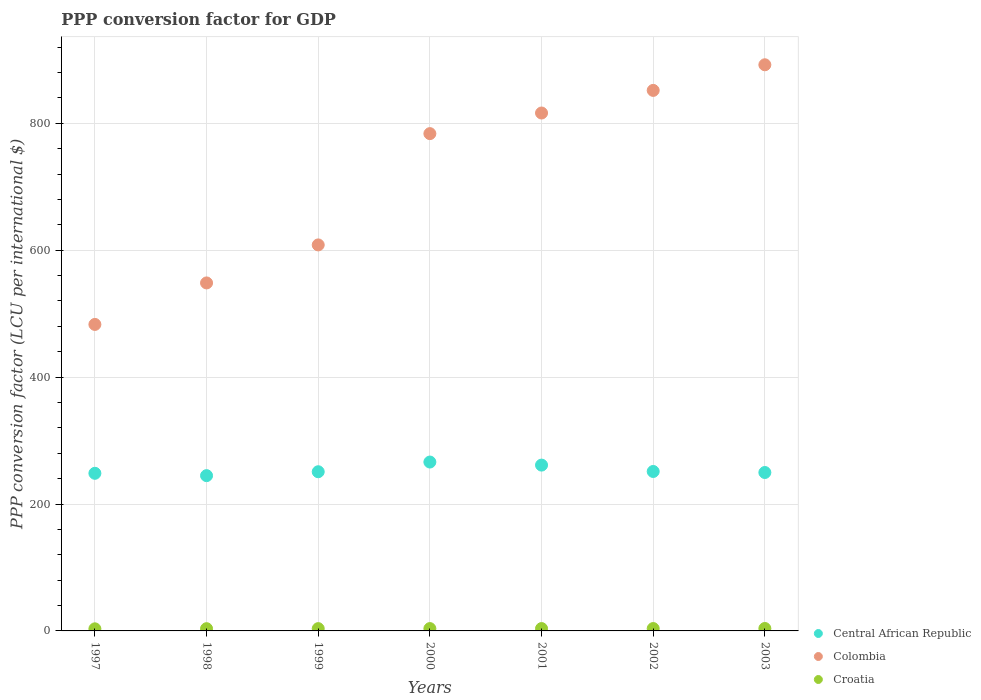How many different coloured dotlines are there?
Make the answer very short. 3. Is the number of dotlines equal to the number of legend labels?
Offer a terse response. Yes. What is the PPP conversion factor for GDP in Colombia in 2000?
Your answer should be compact. 783.73. Across all years, what is the maximum PPP conversion factor for GDP in Central African Republic?
Make the answer very short. 266.16. Across all years, what is the minimum PPP conversion factor for GDP in Croatia?
Make the answer very short. 3.3. In which year was the PPP conversion factor for GDP in Colombia maximum?
Your answer should be very brief. 2003. What is the total PPP conversion factor for GDP in Colombia in the graph?
Provide a short and direct response. 4983.86. What is the difference between the PPP conversion factor for GDP in Croatia in 1998 and that in 2001?
Provide a succinct answer. -0.19. What is the difference between the PPP conversion factor for GDP in Colombia in 2002 and the PPP conversion factor for GDP in Croatia in 1997?
Provide a short and direct response. 848.56. What is the average PPP conversion factor for GDP in Colombia per year?
Make the answer very short. 711.98. In the year 1998, what is the difference between the PPP conversion factor for GDP in Colombia and PPP conversion factor for GDP in Central African Republic?
Your answer should be compact. 303.71. In how many years, is the PPP conversion factor for GDP in Central African Republic greater than 480 LCU?
Offer a terse response. 0. What is the ratio of the PPP conversion factor for GDP in Central African Republic in 1997 to that in 2002?
Make the answer very short. 0.99. Is the difference between the PPP conversion factor for GDP in Colombia in 1998 and 2000 greater than the difference between the PPP conversion factor for GDP in Central African Republic in 1998 and 2000?
Make the answer very short. No. What is the difference between the highest and the second highest PPP conversion factor for GDP in Croatia?
Your response must be concise. 0.1. What is the difference between the highest and the lowest PPP conversion factor for GDP in Central African Republic?
Ensure brevity in your answer.  21.44. In how many years, is the PPP conversion factor for GDP in Central African Republic greater than the average PPP conversion factor for GDP in Central African Republic taken over all years?
Ensure brevity in your answer.  2. Is the sum of the PPP conversion factor for GDP in Colombia in 1998 and 1999 greater than the maximum PPP conversion factor for GDP in Croatia across all years?
Your answer should be very brief. Yes. Is it the case that in every year, the sum of the PPP conversion factor for GDP in Central African Republic and PPP conversion factor for GDP in Croatia  is greater than the PPP conversion factor for GDP in Colombia?
Keep it short and to the point. No. Does the PPP conversion factor for GDP in Central African Republic monotonically increase over the years?
Your response must be concise. No. Is the PPP conversion factor for GDP in Croatia strictly greater than the PPP conversion factor for GDP in Colombia over the years?
Offer a very short reply. No. How many years are there in the graph?
Your response must be concise. 7. What is the difference between two consecutive major ticks on the Y-axis?
Offer a terse response. 200. Are the values on the major ticks of Y-axis written in scientific E-notation?
Provide a short and direct response. No. Does the graph contain grids?
Your answer should be compact. Yes. Where does the legend appear in the graph?
Keep it short and to the point. Bottom right. How are the legend labels stacked?
Provide a short and direct response. Vertical. What is the title of the graph?
Your answer should be very brief. PPP conversion factor for GDP. What is the label or title of the X-axis?
Make the answer very short. Years. What is the label or title of the Y-axis?
Offer a terse response. PPP conversion factor (LCU per international $). What is the PPP conversion factor (LCU per international $) in Central African Republic in 1997?
Offer a terse response. 248.4. What is the PPP conversion factor (LCU per international $) of Colombia in 1997?
Your response must be concise. 483.02. What is the PPP conversion factor (LCU per international $) in Croatia in 1997?
Offer a very short reply. 3.3. What is the PPP conversion factor (LCU per international $) of Central African Republic in 1998?
Provide a succinct answer. 244.72. What is the PPP conversion factor (LCU per international $) of Colombia in 1998?
Keep it short and to the point. 548.43. What is the PPP conversion factor (LCU per international $) of Croatia in 1998?
Provide a short and direct response. 3.52. What is the PPP conversion factor (LCU per international $) of Central African Republic in 1999?
Make the answer very short. 250.87. What is the PPP conversion factor (LCU per international $) in Colombia in 1999?
Give a very brief answer. 608.35. What is the PPP conversion factor (LCU per international $) of Croatia in 1999?
Provide a succinct answer. 3.62. What is the PPP conversion factor (LCU per international $) in Central African Republic in 2000?
Keep it short and to the point. 266.16. What is the PPP conversion factor (LCU per international $) of Colombia in 2000?
Keep it short and to the point. 783.73. What is the PPP conversion factor (LCU per international $) in Croatia in 2000?
Offer a very short reply. 3.68. What is the PPP conversion factor (LCU per international $) of Central African Republic in 2001?
Your answer should be very brief. 261.34. What is the PPP conversion factor (LCU per international $) of Colombia in 2001?
Make the answer very short. 816.22. What is the PPP conversion factor (LCU per international $) of Croatia in 2001?
Provide a short and direct response. 3.71. What is the PPP conversion factor (LCU per international $) in Central African Republic in 2002?
Give a very brief answer. 251.28. What is the PPP conversion factor (LCU per international $) in Colombia in 2002?
Provide a succinct answer. 851.86. What is the PPP conversion factor (LCU per international $) in Croatia in 2002?
Offer a very short reply. 3.74. What is the PPP conversion factor (LCU per international $) in Central African Republic in 2003?
Offer a terse response. 249.66. What is the PPP conversion factor (LCU per international $) of Colombia in 2003?
Give a very brief answer. 892.24. What is the PPP conversion factor (LCU per international $) in Croatia in 2003?
Offer a very short reply. 3.84. Across all years, what is the maximum PPP conversion factor (LCU per international $) in Central African Republic?
Keep it short and to the point. 266.16. Across all years, what is the maximum PPP conversion factor (LCU per international $) in Colombia?
Give a very brief answer. 892.24. Across all years, what is the maximum PPP conversion factor (LCU per international $) of Croatia?
Your answer should be compact. 3.84. Across all years, what is the minimum PPP conversion factor (LCU per international $) of Central African Republic?
Keep it short and to the point. 244.72. Across all years, what is the minimum PPP conversion factor (LCU per international $) of Colombia?
Ensure brevity in your answer.  483.02. Across all years, what is the minimum PPP conversion factor (LCU per international $) in Croatia?
Make the answer very short. 3.3. What is the total PPP conversion factor (LCU per international $) in Central African Republic in the graph?
Make the answer very short. 1772.43. What is the total PPP conversion factor (LCU per international $) in Colombia in the graph?
Your answer should be compact. 4983.86. What is the total PPP conversion factor (LCU per international $) of Croatia in the graph?
Make the answer very short. 25.41. What is the difference between the PPP conversion factor (LCU per international $) of Central African Republic in 1997 and that in 1998?
Provide a succinct answer. 3.68. What is the difference between the PPP conversion factor (LCU per international $) of Colombia in 1997 and that in 1998?
Keep it short and to the point. -65.41. What is the difference between the PPP conversion factor (LCU per international $) of Croatia in 1997 and that in 1998?
Offer a terse response. -0.22. What is the difference between the PPP conversion factor (LCU per international $) of Central African Republic in 1997 and that in 1999?
Offer a very short reply. -2.47. What is the difference between the PPP conversion factor (LCU per international $) of Colombia in 1997 and that in 1999?
Offer a terse response. -125.32. What is the difference between the PPP conversion factor (LCU per international $) in Croatia in 1997 and that in 1999?
Your answer should be compact. -0.31. What is the difference between the PPP conversion factor (LCU per international $) in Central African Republic in 1997 and that in 2000?
Ensure brevity in your answer.  -17.76. What is the difference between the PPP conversion factor (LCU per international $) in Colombia in 1997 and that in 2000?
Your answer should be compact. -300.71. What is the difference between the PPP conversion factor (LCU per international $) of Croatia in 1997 and that in 2000?
Offer a terse response. -0.38. What is the difference between the PPP conversion factor (LCU per international $) of Central African Republic in 1997 and that in 2001?
Keep it short and to the point. -12.94. What is the difference between the PPP conversion factor (LCU per international $) in Colombia in 1997 and that in 2001?
Offer a very short reply. -333.2. What is the difference between the PPP conversion factor (LCU per international $) in Croatia in 1997 and that in 2001?
Give a very brief answer. -0.41. What is the difference between the PPP conversion factor (LCU per international $) in Central African Republic in 1997 and that in 2002?
Ensure brevity in your answer.  -2.88. What is the difference between the PPP conversion factor (LCU per international $) in Colombia in 1997 and that in 2002?
Offer a terse response. -368.83. What is the difference between the PPP conversion factor (LCU per international $) of Croatia in 1997 and that in 2002?
Offer a very short reply. -0.44. What is the difference between the PPP conversion factor (LCU per international $) of Central African Republic in 1997 and that in 2003?
Offer a terse response. -1.26. What is the difference between the PPP conversion factor (LCU per international $) of Colombia in 1997 and that in 2003?
Offer a very short reply. -409.21. What is the difference between the PPP conversion factor (LCU per international $) in Croatia in 1997 and that in 2003?
Ensure brevity in your answer.  -0.53. What is the difference between the PPP conversion factor (LCU per international $) of Central African Republic in 1998 and that in 1999?
Your response must be concise. -6.16. What is the difference between the PPP conversion factor (LCU per international $) in Colombia in 1998 and that in 1999?
Provide a succinct answer. -59.92. What is the difference between the PPP conversion factor (LCU per international $) of Croatia in 1998 and that in 1999?
Keep it short and to the point. -0.09. What is the difference between the PPP conversion factor (LCU per international $) in Central African Republic in 1998 and that in 2000?
Provide a succinct answer. -21.44. What is the difference between the PPP conversion factor (LCU per international $) of Colombia in 1998 and that in 2000?
Provide a short and direct response. -235.3. What is the difference between the PPP conversion factor (LCU per international $) in Croatia in 1998 and that in 2000?
Offer a terse response. -0.16. What is the difference between the PPP conversion factor (LCU per international $) of Central African Republic in 1998 and that in 2001?
Your answer should be very brief. -16.62. What is the difference between the PPP conversion factor (LCU per international $) in Colombia in 1998 and that in 2001?
Keep it short and to the point. -267.79. What is the difference between the PPP conversion factor (LCU per international $) in Croatia in 1998 and that in 2001?
Give a very brief answer. -0.19. What is the difference between the PPP conversion factor (LCU per international $) in Central African Republic in 1998 and that in 2002?
Offer a terse response. -6.56. What is the difference between the PPP conversion factor (LCU per international $) in Colombia in 1998 and that in 2002?
Your answer should be compact. -303.43. What is the difference between the PPP conversion factor (LCU per international $) in Croatia in 1998 and that in 2002?
Your answer should be very brief. -0.22. What is the difference between the PPP conversion factor (LCU per international $) of Central African Republic in 1998 and that in 2003?
Your answer should be compact. -4.94. What is the difference between the PPP conversion factor (LCU per international $) of Colombia in 1998 and that in 2003?
Make the answer very short. -343.81. What is the difference between the PPP conversion factor (LCU per international $) in Croatia in 1998 and that in 2003?
Offer a very short reply. -0.32. What is the difference between the PPP conversion factor (LCU per international $) in Central African Republic in 1999 and that in 2000?
Give a very brief answer. -15.28. What is the difference between the PPP conversion factor (LCU per international $) of Colombia in 1999 and that in 2000?
Your answer should be very brief. -175.39. What is the difference between the PPP conversion factor (LCU per international $) in Croatia in 1999 and that in 2000?
Keep it short and to the point. -0.07. What is the difference between the PPP conversion factor (LCU per international $) in Central African Republic in 1999 and that in 2001?
Your answer should be compact. -10.46. What is the difference between the PPP conversion factor (LCU per international $) of Colombia in 1999 and that in 2001?
Give a very brief answer. -207.87. What is the difference between the PPP conversion factor (LCU per international $) in Croatia in 1999 and that in 2001?
Ensure brevity in your answer.  -0.1. What is the difference between the PPP conversion factor (LCU per international $) in Central African Republic in 1999 and that in 2002?
Offer a terse response. -0.41. What is the difference between the PPP conversion factor (LCU per international $) in Colombia in 1999 and that in 2002?
Provide a succinct answer. -243.51. What is the difference between the PPP conversion factor (LCU per international $) of Croatia in 1999 and that in 2002?
Your answer should be compact. -0.13. What is the difference between the PPP conversion factor (LCU per international $) in Central African Republic in 1999 and that in 2003?
Offer a very short reply. 1.21. What is the difference between the PPP conversion factor (LCU per international $) in Colombia in 1999 and that in 2003?
Give a very brief answer. -283.89. What is the difference between the PPP conversion factor (LCU per international $) of Croatia in 1999 and that in 2003?
Make the answer very short. -0.22. What is the difference between the PPP conversion factor (LCU per international $) of Central African Republic in 2000 and that in 2001?
Ensure brevity in your answer.  4.82. What is the difference between the PPP conversion factor (LCU per international $) of Colombia in 2000 and that in 2001?
Offer a very short reply. -32.49. What is the difference between the PPP conversion factor (LCU per international $) in Croatia in 2000 and that in 2001?
Give a very brief answer. -0.03. What is the difference between the PPP conversion factor (LCU per international $) of Central African Republic in 2000 and that in 2002?
Your answer should be compact. 14.88. What is the difference between the PPP conversion factor (LCU per international $) of Colombia in 2000 and that in 2002?
Provide a short and direct response. -68.12. What is the difference between the PPP conversion factor (LCU per international $) of Croatia in 2000 and that in 2002?
Offer a very short reply. -0.06. What is the difference between the PPP conversion factor (LCU per international $) in Central African Republic in 2000 and that in 2003?
Keep it short and to the point. 16.5. What is the difference between the PPP conversion factor (LCU per international $) of Colombia in 2000 and that in 2003?
Provide a succinct answer. -108.5. What is the difference between the PPP conversion factor (LCU per international $) of Croatia in 2000 and that in 2003?
Ensure brevity in your answer.  -0.15. What is the difference between the PPP conversion factor (LCU per international $) in Central African Republic in 2001 and that in 2002?
Give a very brief answer. 10.06. What is the difference between the PPP conversion factor (LCU per international $) in Colombia in 2001 and that in 2002?
Offer a terse response. -35.64. What is the difference between the PPP conversion factor (LCU per international $) in Croatia in 2001 and that in 2002?
Ensure brevity in your answer.  -0.03. What is the difference between the PPP conversion factor (LCU per international $) of Central African Republic in 2001 and that in 2003?
Make the answer very short. 11.68. What is the difference between the PPP conversion factor (LCU per international $) of Colombia in 2001 and that in 2003?
Offer a very short reply. -76.02. What is the difference between the PPP conversion factor (LCU per international $) in Croatia in 2001 and that in 2003?
Make the answer very short. -0.13. What is the difference between the PPP conversion factor (LCU per international $) of Central African Republic in 2002 and that in 2003?
Make the answer very short. 1.62. What is the difference between the PPP conversion factor (LCU per international $) of Colombia in 2002 and that in 2003?
Give a very brief answer. -40.38. What is the difference between the PPP conversion factor (LCU per international $) of Croatia in 2002 and that in 2003?
Your response must be concise. -0.1. What is the difference between the PPP conversion factor (LCU per international $) of Central African Republic in 1997 and the PPP conversion factor (LCU per international $) of Colombia in 1998?
Offer a terse response. -300.03. What is the difference between the PPP conversion factor (LCU per international $) in Central African Republic in 1997 and the PPP conversion factor (LCU per international $) in Croatia in 1998?
Give a very brief answer. 244.88. What is the difference between the PPP conversion factor (LCU per international $) in Colombia in 1997 and the PPP conversion factor (LCU per international $) in Croatia in 1998?
Give a very brief answer. 479.5. What is the difference between the PPP conversion factor (LCU per international $) of Central African Republic in 1997 and the PPP conversion factor (LCU per international $) of Colombia in 1999?
Your answer should be very brief. -359.95. What is the difference between the PPP conversion factor (LCU per international $) of Central African Republic in 1997 and the PPP conversion factor (LCU per international $) of Croatia in 1999?
Your answer should be compact. 244.79. What is the difference between the PPP conversion factor (LCU per international $) of Colombia in 1997 and the PPP conversion factor (LCU per international $) of Croatia in 1999?
Offer a very short reply. 479.41. What is the difference between the PPP conversion factor (LCU per international $) in Central African Republic in 1997 and the PPP conversion factor (LCU per international $) in Colombia in 2000?
Your answer should be compact. -535.33. What is the difference between the PPP conversion factor (LCU per international $) in Central African Republic in 1997 and the PPP conversion factor (LCU per international $) in Croatia in 2000?
Ensure brevity in your answer.  244.72. What is the difference between the PPP conversion factor (LCU per international $) of Colombia in 1997 and the PPP conversion factor (LCU per international $) of Croatia in 2000?
Your answer should be very brief. 479.34. What is the difference between the PPP conversion factor (LCU per international $) in Central African Republic in 1997 and the PPP conversion factor (LCU per international $) in Colombia in 2001?
Ensure brevity in your answer.  -567.82. What is the difference between the PPP conversion factor (LCU per international $) in Central African Republic in 1997 and the PPP conversion factor (LCU per international $) in Croatia in 2001?
Provide a succinct answer. 244.69. What is the difference between the PPP conversion factor (LCU per international $) of Colombia in 1997 and the PPP conversion factor (LCU per international $) of Croatia in 2001?
Your answer should be compact. 479.31. What is the difference between the PPP conversion factor (LCU per international $) in Central African Republic in 1997 and the PPP conversion factor (LCU per international $) in Colombia in 2002?
Make the answer very short. -603.46. What is the difference between the PPP conversion factor (LCU per international $) of Central African Republic in 1997 and the PPP conversion factor (LCU per international $) of Croatia in 2002?
Make the answer very short. 244.66. What is the difference between the PPP conversion factor (LCU per international $) of Colombia in 1997 and the PPP conversion factor (LCU per international $) of Croatia in 2002?
Provide a succinct answer. 479.28. What is the difference between the PPP conversion factor (LCU per international $) in Central African Republic in 1997 and the PPP conversion factor (LCU per international $) in Colombia in 2003?
Provide a short and direct response. -643.84. What is the difference between the PPP conversion factor (LCU per international $) in Central African Republic in 1997 and the PPP conversion factor (LCU per international $) in Croatia in 2003?
Give a very brief answer. 244.57. What is the difference between the PPP conversion factor (LCU per international $) of Colombia in 1997 and the PPP conversion factor (LCU per international $) of Croatia in 2003?
Ensure brevity in your answer.  479.19. What is the difference between the PPP conversion factor (LCU per international $) of Central African Republic in 1998 and the PPP conversion factor (LCU per international $) of Colombia in 1999?
Provide a succinct answer. -363.63. What is the difference between the PPP conversion factor (LCU per international $) in Central African Republic in 1998 and the PPP conversion factor (LCU per international $) in Croatia in 1999?
Your response must be concise. 241.1. What is the difference between the PPP conversion factor (LCU per international $) of Colombia in 1998 and the PPP conversion factor (LCU per international $) of Croatia in 1999?
Your response must be concise. 544.82. What is the difference between the PPP conversion factor (LCU per international $) in Central African Republic in 1998 and the PPP conversion factor (LCU per international $) in Colombia in 2000?
Your answer should be very brief. -539.02. What is the difference between the PPP conversion factor (LCU per international $) in Central African Republic in 1998 and the PPP conversion factor (LCU per international $) in Croatia in 2000?
Offer a very short reply. 241.04. What is the difference between the PPP conversion factor (LCU per international $) in Colombia in 1998 and the PPP conversion factor (LCU per international $) in Croatia in 2000?
Your response must be concise. 544.75. What is the difference between the PPP conversion factor (LCU per international $) of Central African Republic in 1998 and the PPP conversion factor (LCU per international $) of Colombia in 2001?
Ensure brevity in your answer.  -571.5. What is the difference between the PPP conversion factor (LCU per international $) in Central African Republic in 1998 and the PPP conversion factor (LCU per international $) in Croatia in 2001?
Offer a very short reply. 241.01. What is the difference between the PPP conversion factor (LCU per international $) in Colombia in 1998 and the PPP conversion factor (LCU per international $) in Croatia in 2001?
Your answer should be compact. 544.72. What is the difference between the PPP conversion factor (LCU per international $) in Central African Republic in 1998 and the PPP conversion factor (LCU per international $) in Colombia in 2002?
Give a very brief answer. -607.14. What is the difference between the PPP conversion factor (LCU per international $) of Central African Republic in 1998 and the PPP conversion factor (LCU per international $) of Croatia in 2002?
Your response must be concise. 240.98. What is the difference between the PPP conversion factor (LCU per international $) of Colombia in 1998 and the PPP conversion factor (LCU per international $) of Croatia in 2002?
Your answer should be very brief. 544.69. What is the difference between the PPP conversion factor (LCU per international $) in Central African Republic in 1998 and the PPP conversion factor (LCU per international $) in Colombia in 2003?
Offer a terse response. -647.52. What is the difference between the PPP conversion factor (LCU per international $) of Central African Republic in 1998 and the PPP conversion factor (LCU per international $) of Croatia in 2003?
Your answer should be very brief. 240.88. What is the difference between the PPP conversion factor (LCU per international $) in Colombia in 1998 and the PPP conversion factor (LCU per international $) in Croatia in 2003?
Ensure brevity in your answer.  544.59. What is the difference between the PPP conversion factor (LCU per international $) of Central African Republic in 1999 and the PPP conversion factor (LCU per international $) of Colombia in 2000?
Your answer should be compact. -532.86. What is the difference between the PPP conversion factor (LCU per international $) of Central African Republic in 1999 and the PPP conversion factor (LCU per international $) of Croatia in 2000?
Your answer should be very brief. 247.19. What is the difference between the PPP conversion factor (LCU per international $) of Colombia in 1999 and the PPP conversion factor (LCU per international $) of Croatia in 2000?
Your answer should be compact. 604.67. What is the difference between the PPP conversion factor (LCU per international $) of Central African Republic in 1999 and the PPP conversion factor (LCU per international $) of Colombia in 2001?
Provide a succinct answer. -565.35. What is the difference between the PPP conversion factor (LCU per international $) in Central African Republic in 1999 and the PPP conversion factor (LCU per international $) in Croatia in 2001?
Your answer should be very brief. 247.16. What is the difference between the PPP conversion factor (LCU per international $) in Colombia in 1999 and the PPP conversion factor (LCU per international $) in Croatia in 2001?
Ensure brevity in your answer.  604.64. What is the difference between the PPP conversion factor (LCU per international $) in Central African Republic in 1999 and the PPP conversion factor (LCU per international $) in Colombia in 2002?
Offer a terse response. -600.98. What is the difference between the PPP conversion factor (LCU per international $) in Central African Republic in 1999 and the PPP conversion factor (LCU per international $) in Croatia in 2002?
Your response must be concise. 247.13. What is the difference between the PPP conversion factor (LCU per international $) of Colombia in 1999 and the PPP conversion factor (LCU per international $) of Croatia in 2002?
Keep it short and to the point. 604.61. What is the difference between the PPP conversion factor (LCU per international $) of Central African Republic in 1999 and the PPP conversion factor (LCU per international $) of Colombia in 2003?
Your response must be concise. -641.36. What is the difference between the PPP conversion factor (LCU per international $) in Central African Republic in 1999 and the PPP conversion factor (LCU per international $) in Croatia in 2003?
Your answer should be very brief. 247.04. What is the difference between the PPP conversion factor (LCU per international $) of Colombia in 1999 and the PPP conversion factor (LCU per international $) of Croatia in 2003?
Offer a very short reply. 604.51. What is the difference between the PPP conversion factor (LCU per international $) of Central African Republic in 2000 and the PPP conversion factor (LCU per international $) of Colombia in 2001?
Your answer should be compact. -550.06. What is the difference between the PPP conversion factor (LCU per international $) of Central African Republic in 2000 and the PPP conversion factor (LCU per international $) of Croatia in 2001?
Ensure brevity in your answer.  262.45. What is the difference between the PPP conversion factor (LCU per international $) in Colombia in 2000 and the PPP conversion factor (LCU per international $) in Croatia in 2001?
Provide a short and direct response. 780.02. What is the difference between the PPP conversion factor (LCU per international $) in Central African Republic in 2000 and the PPP conversion factor (LCU per international $) in Colombia in 2002?
Offer a terse response. -585.7. What is the difference between the PPP conversion factor (LCU per international $) in Central African Republic in 2000 and the PPP conversion factor (LCU per international $) in Croatia in 2002?
Give a very brief answer. 262.42. What is the difference between the PPP conversion factor (LCU per international $) of Colombia in 2000 and the PPP conversion factor (LCU per international $) of Croatia in 2002?
Give a very brief answer. 779.99. What is the difference between the PPP conversion factor (LCU per international $) of Central African Republic in 2000 and the PPP conversion factor (LCU per international $) of Colombia in 2003?
Your answer should be very brief. -626.08. What is the difference between the PPP conversion factor (LCU per international $) in Central African Republic in 2000 and the PPP conversion factor (LCU per international $) in Croatia in 2003?
Give a very brief answer. 262.32. What is the difference between the PPP conversion factor (LCU per international $) in Colombia in 2000 and the PPP conversion factor (LCU per international $) in Croatia in 2003?
Provide a short and direct response. 779.9. What is the difference between the PPP conversion factor (LCU per international $) in Central African Republic in 2001 and the PPP conversion factor (LCU per international $) in Colombia in 2002?
Offer a terse response. -590.52. What is the difference between the PPP conversion factor (LCU per international $) of Central African Republic in 2001 and the PPP conversion factor (LCU per international $) of Croatia in 2002?
Give a very brief answer. 257.6. What is the difference between the PPP conversion factor (LCU per international $) of Colombia in 2001 and the PPP conversion factor (LCU per international $) of Croatia in 2002?
Make the answer very short. 812.48. What is the difference between the PPP conversion factor (LCU per international $) of Central African Republic in 2001 and the PPP conversion factor (LCU per international $) of Colombia in 2003?
Your answer should be very brief. -630.9. What is the difference between the PPP conversion factor (LCU per international $) of Central African Republic in 2001 and the PPP conversion factor (LCU per international $) of Croatia in 2003?
Your response must be concise. 257.5. What is the difference between the PPP conversion factor (LCU per international $) of Colombia in 2001 and the PPP conversion factor (LCU per international $) of Croatia in 2003?
Keep it short and to the point. 812.38. What is the difference between the PPP conversion factor (LCU per international $) in Central African Republic in 2002 and the PPP conversion factor (LCU per international $) in Colombia in 2003?
Offer a terse response. -640.96. What is the difference between the PPP conversion factor (LCU per international $) of Central African Republic in 2002 and the PPP conversion factor (LCU per international $) of Croatia in 2003?
Your answer should be very brief. 247.45. What is the difference between the PPP conversion factor (LCU per international $) in Colombia in 2002 and the PPP conversion factor (LCU per international $) in Croatia in 2003?
Give a very brief answer. 848.02. What is the average PPP conversion factor (LCU per international $) of Central African Republic per year?
Provide a short and direct response. 253.21. What is the average PPP conversion factor (LCU per international $) of Colombia per year?
Provide a succinct answer. 711.98. What is the average PPP conversion factor (LCU per international $) in Croatia per year?
Keep it short and to the point. 3.63. In the year 1997, what is the difference between the PPP conversion factor (LCU per international $) in Central African Republic and PPP conversion factor (LCU per international $) in Colombia?
Provide a short and direct response. -234.62. In the year 1997, what is the difference between the PPP conversion factor (LCU per international $) in Central African Republic and PPP conversion factor (LCU per international $) in Croatia?
Your answer should be very brief. 245.1. In the year 1997, what is the difference between the PPP conversion factor (LCU per international $) of Colombia and PPP conversion factor (LCU per international $) of Croatia?
Make the answer very short. 479.72. In the year 1998, what is the difference between the PPP conversion factor (LCU per international $) of Central African Republic and PPP conversion factor (LCU per international $) of Colombia?
Make the answer very short. -303.71. In the year 1998, what is the difference between the PPP conversion factor (LCU per international $) of Central African Republic and PPP conversion factor (LCU per international $) of Croatia?
Keep it short and to the point. 241.2. In the year 1998, what is the difference between the PPP conversion factor (LCU per international $) in Colombia and PPP conversion factor (LCU per international $) in Croatia?
Ensure brevity in your answer.  544.91. In the year 1999, what is the difference between the PPP conversion factor (LCU per international $) in Central African Republic and PPP conversion factor (LCU per international $) in Colombia?
Your answer should be very brief. -357.47. In the year 1999, what is the difference between the PPP conversion factor (LCU per international $) in Central African Republic and PPP conversion factor (LCU per international $) in Croatia?
Provide a succinct answer. 247.26. In the year 1999, what is the difference between the PPP conversion factor (LCU per international $) in Colombia and PPP conversion factor (LCU per international $) in Croatia?
Ensure brevity in your answer.  604.73. In the year 2000, what is the difference between the PPP conversion factor (LCU per international $) in Central African Republic and PPP conversion factor (LCU per international $) in Colombia?
Offer a very short reply. -517.58. In the year 2000, what is the difference between the PPP conversion factor (LCU per international $) of Central African Republic and PPP conversion factor (LCU per international $) of Croatia?
Provide a short and direct response. 262.48. In the year 2000, what is the difference between the PPP conversion factor (LCU per international $) in Colombia and PPP conversion factor (LCU per international $) in Croatia?
Provide a short and direct response. 780.05. In the year 2001, what is the difference between the PPP conversion factor (LCU per international $) in Central African Republic and PPP conversion factor (LCU per international $) in Colombia?
Ensure brevity in your answer.  -554.88. In the year 2001, what is the difference between the PPP conversion factor (LCU per international $) in Central African Republic and PPP conversion factor (LCU per international $) in Croatia?
Offer a very short reply. 257.63. In the year 2001, what is the difference between the PPP conversion factor (LCU per international $) of Colombia and PPP conversion factor (LCU per international $) of Croatia?
Your answer should be compact. 812.51. In the year 2002, what is the difference between the PPP conversion factor (LCU per international $) in Central African Republic and PPP conversion factor (LCU per international $) in Colombia?
Provide a succinct answer. -600.58. In the year 2002, what is the difference between the PPP conversion factor (LCU per international $) of Central African Republic and PPP conversion factor (LCU per international $) of Croatia?
Your response must be concise. 247.54. In the year 2002, what is the difference between the PPP conversion factor (LCU per international $) of Colombia and PPP conversion factor (LCU per international $) of Croatia?
Keep it short and to the point. 848.12. In the year 2003, what is the difference between the PPP conversion factor (LCU per international $) in Central African Republic and PPP conversion factor (LCU per international $) in Colombia?
Make the answer very short. -642.58. In the year 2003, what is the difference between the PPP conversion factor (LCU per international $) in Central African Republic and PPP conversion factor (LCU per international $) in Croatia?
Give a very brief answer. 245.82. In the year 2003, what is the difference between the PPP conversion factor (LCU per international $) in Colombia and PPP conversion factor (LCU per international $) in Croatia?
Your response must be concise. 888.4. What is the ratio of the PPP conversion factor (LCU per international $) in Central African Republic in 1997 to that in 1998?
Your response must be concise. 1.02. What is the ratio of the PPP conversion factor (LCU per international $) in Colombia in 1997 to that in 1998?
Your answer should be compact. 0.88. What is the ratio of the PPP conversion factor (LCU per international $) of Croatia in 1997 to that in 1998?
Provide a succinct answer. 0.94. What is the ratio of the PPP conversion factor (LCU per international $) of Central African Republic in 1997 to that in 1999?
Make the answer very short. 0.99. What is the ratio of the PPP conversion factor (LCU per international $) in Colombia in 1997 to that in 1999?
Provide a succinct answer. 0.79. What is the ratio of the PPP conversion factor (LCU per international $) in Croatia in 1997 to that in 1999?
Provide a succinct answer. 0.91. What is the ratio of the PPP conversion factor (LCU per international $) in Colombia in 1997 to that in 2000?
Your answer should be very brief. 0.62. What is the ratio of the PPP conversion factor (LCU per international $) in Croatia in 1997 to that in 2000?
Keep it short and to the point. 0.9. What is the ratio of the PPP conversion factor (LCU per international $) in Central African Republic in 1997 to that in 2001?
Provide a succinct answer. 0.95. What is the ratio of the PPP conversion factor (LCU per international $) of Colombia in 1997 to that in 2001?
Provide a short and direct response. 0.59. What is the ratio of the PPP conversion factor (LCU per international $) in Croatia in 1997 to that in 2001?
Your answer should be very brief. 0.89. What is the ratio of the PPP conversion factor (LCU per international $) in Colombia in 1997 to that in 2002?
Provide a succinct answer. 0.57. What is the ratio of the PPP conversion factor (LCU per international $) in Croatia in 1997 to that in 2002?
Your answer should be very brief. 0.88. What is the ratio of the PPP conversion factor (LCU per international $) in Colombia in 1997 to that in 2003?
Your answer should be very brief. 0.54. What is the ratio of the PPP conversion factor (LCU per international $) of Croatia in 1997 to that in 2003?
Give a very brief answer. 0.86. What is the ratio of the PPP conversion factor (LCU per international $) of Central African Republic in 1998 to that in 1999?
Provide a succinct answer. 0.98. What is the ratio of the PPP conversion factor (LCU per international $) of Colombia in 1998 to that in 1999?
Ensure brevity in your answer.  0.9. What is the ratio of the PPP conversion factor (LCU per international $) of Croatia in 1998 to that in 1999?
Your response must be concise. 0.97. What is the ratio of the PPP conversion factor (LCU per international $) in Central African Republic in 1998 to that in 2000?
Your answer should be very brief. 0.92. What is the ratio of the PPP conversion factor (LCU per international $) in Colombia in 1998 to that in 2000?
Make the answer very short. 0.7. What is the ratio of the PPP conversion factor (LCU per international $) in Croatia in 1998 to that in 2000?
Provide a succinct answer. 0.96. What is the ratio of the PPP conversion factor (LCU per international $) in Central African Republic in 1998 to that in 2001?
Keep it short and to the point. 0.94. What is the ratio of the PPP conversion factor (LCU per international $) in Colombia in 1998 to that in 2001?
Offer a terse response. 0.67. What is the ratio of the PPP conversion factor (LCU per international $) of Croatia in 1998 to that in 2001?
Offer a terse response. 0.95. What is the ratio of the PPP conversion factor (LCU per international $) of Central African Republic in 1998 to that in 2002?
Offer a terse response. 0.97. What is the ratio of the PPP conversion factor (LCU per international $) in Colombia in 1998 to that in 2002?
Make the answer very short. 0.64. What is the ratio of the PPP conversion factor (LCU per international $) of Croatia in 1998 to that in 2002?
Offer a terse response. 0.94. What is the ratio of the PPP conversion factor (LCU per international $) of Central African Republic in 1998 to that in 2003?
Your response must be concise. 0.98. What is the ratio of the PPP conversion factor (LCU per international $) in Colombia in 1998 to that in 2003?
Offer a very short reply. 0.61. What is the ratio of the PPP conversion factor (LCU per international $) of Croatia in 1998 to that in 2003?
Your answer should be very brief. 0.92. What is the ratio of the PPP conversion factor (LCU per international $) in Central African Republic in 1999 to that in 2000?
Offer a very short reply. 0.94. What is the ratio of the PPP conversion factor (LCU per international $) of Colombia in 1999 to that in 2000?
Offer a terse response. 0.78. What is the ratio of the PPP conversion factor (LCU per international $) in Croatia in 1999 to that in 2000?
Provide a short and direct response. 0.98. What is the ratio of the PPP conversion factor (LCU per international $) in Colombia in 1999 to that in 2001?
Offer a terse response. 0.75. What is the ratio of the PPP conversion factor (LCU per international $) of Croatia in 1999 to that in 2001?
Ensure brevity in your answer.  0.97. What is the ratio of the PPP conversion factor (LCU per international $) in Colombia in 1999 to that in 2002?
Offer a very short reply. 0.71. What is the ratio of the PPP conversion factor (LCU per international $) in Croatia in 1999 to that in 2002?
Give a very brief answer. 0.97. What is the ratio of the PPP conversion factor (LCU per international $) in Central African Republic in 1999 to that in 2003?
Offer a terse response. 1. What is the ratio of the PPP conversion factor (LCU per international $) of Colombia in 1999 to that in 2003?
Offer a terse response. 0.68. What is the ratio of the PPP conversion factor (LCU per international $) in Croatia in 1999 to that in 2003?
Make the answer very short. 0.94. What is the ratio of the PPP conversion factor (LCU per international $) of Central African Republic in 2000 to that in 2001?
Make the answer very short. 1.02. What is the ratio of the PPP conversion factor (LCU per international $) of Colombia in 2000 to that in 2001?
Offer a very short reply. 0.96. What is the ratio of the PPP conversion factor (LCU per international $) in Croatia in 2000 to that in 2001?
Provide a succinct answer. 0.99. What is the ratio of the PPP conversion factor (LCU per international $) in Central African Republic in 2000 to that in 2002?
Provide a succinct answer. 1.06. What is the ratio of the PPP conversion factor (LCU per international $) in Croatia in 2000 to that in 2002?
Your answer should be very brief. 0.98. What is the ratio of the PPP conversion factor (LCU per international $) in Central African Republic in 2000 to that in 2003?
Your response must be concise. 1.07. What is the ratio of the PPP conversion factor (LCU per international $) of Colombia in 2000 to that in 2003?
Ensure brevity in your answer.  0.88. What is the ratio of the PPP conversion factor (LCU per international $) of Croatia in 2000 to that in 2003?
Provide a succinct answer. 0.96. What is the ratio of the PPP conversion factor (LCU per international $) in Central African Republic in 2001 to that in 2002?
Your answer should be very brief. 1.04. What is the ratio of the PPP conversion factor (LCU per international $) in Colombia in 2001 to that in 2002?
Your response must be concise. 0.96. What is the ratio of the PPP conversion factor (LCU per international $) in Croatia in 2001 to that in 2002?
Your answer should be compact. 0.99. What is the ratio of the PPP conversion factor (LCU per international $) in Central African Republic in 2001 to that in 2003?
Ensure brevity in your answer.  1.05. What is the ratio of the PPP conversion factor (LCU per international $) of Colombia in 2001 to that in 2003?
Make the answer very short. 0.91. What is the ratio of the PPP conversion factor (LCU per international $) in Croatia in 2001 to that in 2003?
Your answer should be very brief. 0.97. What is the ratio of the PPP conversion factor (LCU per international $) in Central African Republic in 2002 to that in 2003?
Your answer should be very brief. 1.01. What is the ratio of the PPP conversion factor (LCU per international $) of Colombia in 2002 to that in 2003?
Your answer should be very brief. 0.95. What is the difference between the highest and the second highest PPP conversion factor (LCU per international $) of Central African Republic?
Provide a succinct answer. 4.82. What is the difference between the highest and the second highest PPP conversion factor (LCU per international $) in Colombia?
Make the answer very short. 40.38. What is the difference between the highest and the second highest PPP conversion factor (LCU per international $) of Croatia?
Keep it short and to the point. 0.1. What is the difference between the highest and the lowest PPP conversion factor (LCU per international $) of Central African Republic?
Ensure brevity in your answer.  21.44. What is the difference between the highest and the lowest PPP conversion factor (LCU per international $) of Colombia?
Offer a terse response. 409.21. What is the difference between the highest and the lowest PPP conversion factor (LCU per international $) in Croatia?
Your response must be concise. 0.53. 